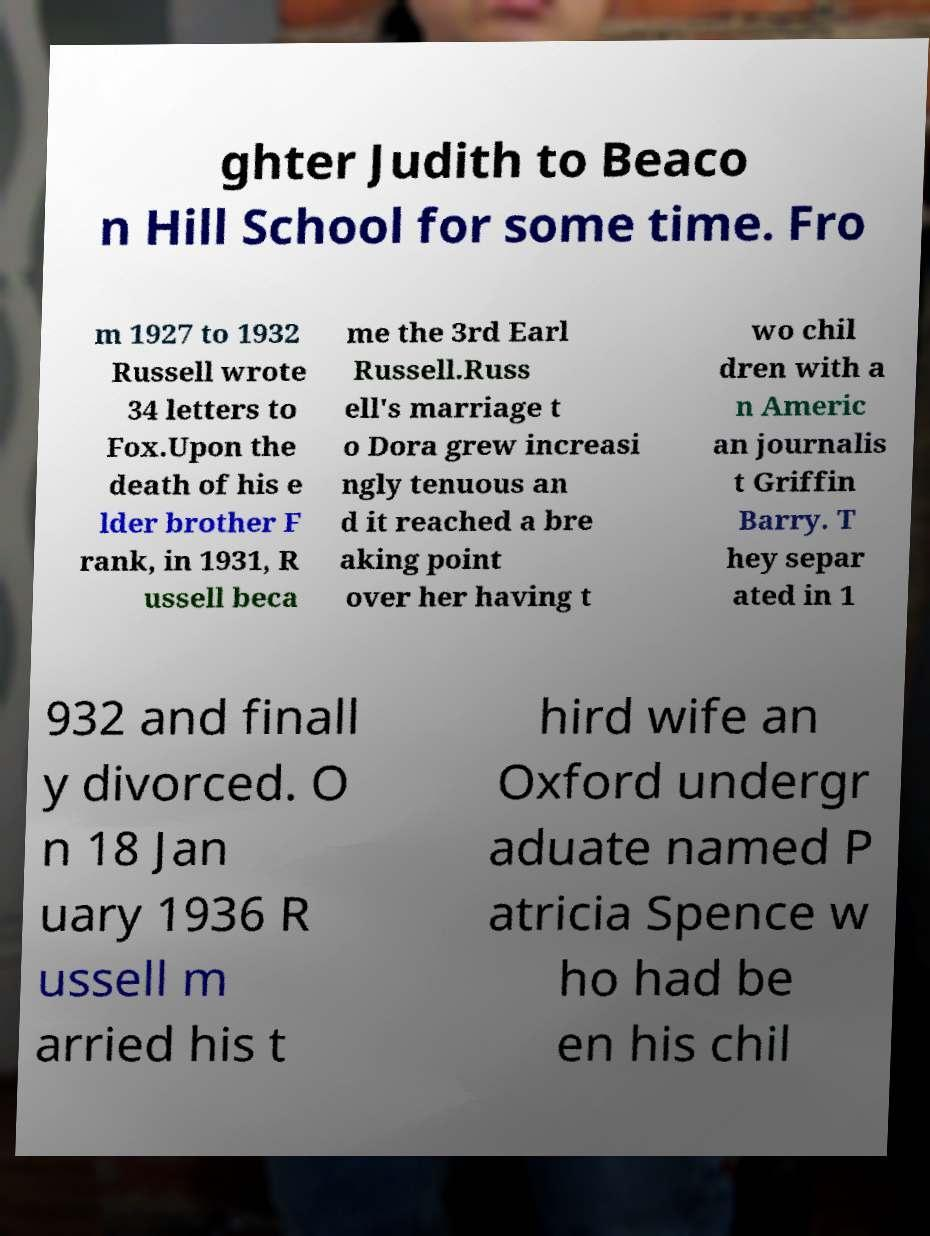Can you read and provide the text displayed in the image?This photo seems to have some interesting text. Can you extract and type it out for me? ghter Judith to Beaco n Hill School for some time. Fro m 1927 to 1932 Russell wrote 34 letters to Fox.Upon the death of his e lder brother F rank, in 1931, R ussell beca me the 3rd Earl Russell.Russ ell's marriage t o Dora grew increasi ngly tenuous an d it reached a bre aking point over her having t wo chil dren with a n Americ an journalis t Griffin Barry. T hey separ ated in 1 932 and finall y divorced. O n 18 Jan uary 1936 R ussell m arried his t hird wife an Oxford undergr aduate named P atricia Spence w ho had be en his chil 